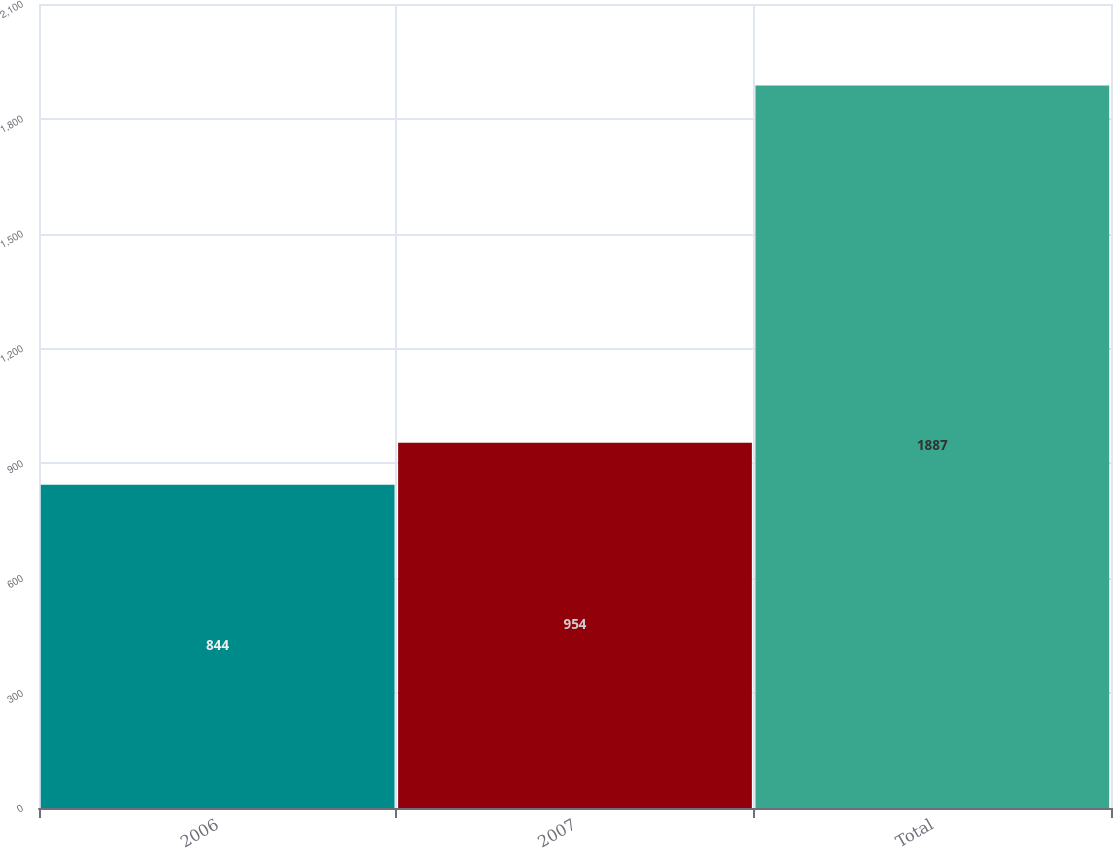<chart> <loc_0><loc_0><loc_500><loc_500><bar_chart><fcel>2006<fcel>2007<fcel>Total<nl><fcel>844<fcel>954<fcel>1887<nl></chart> 